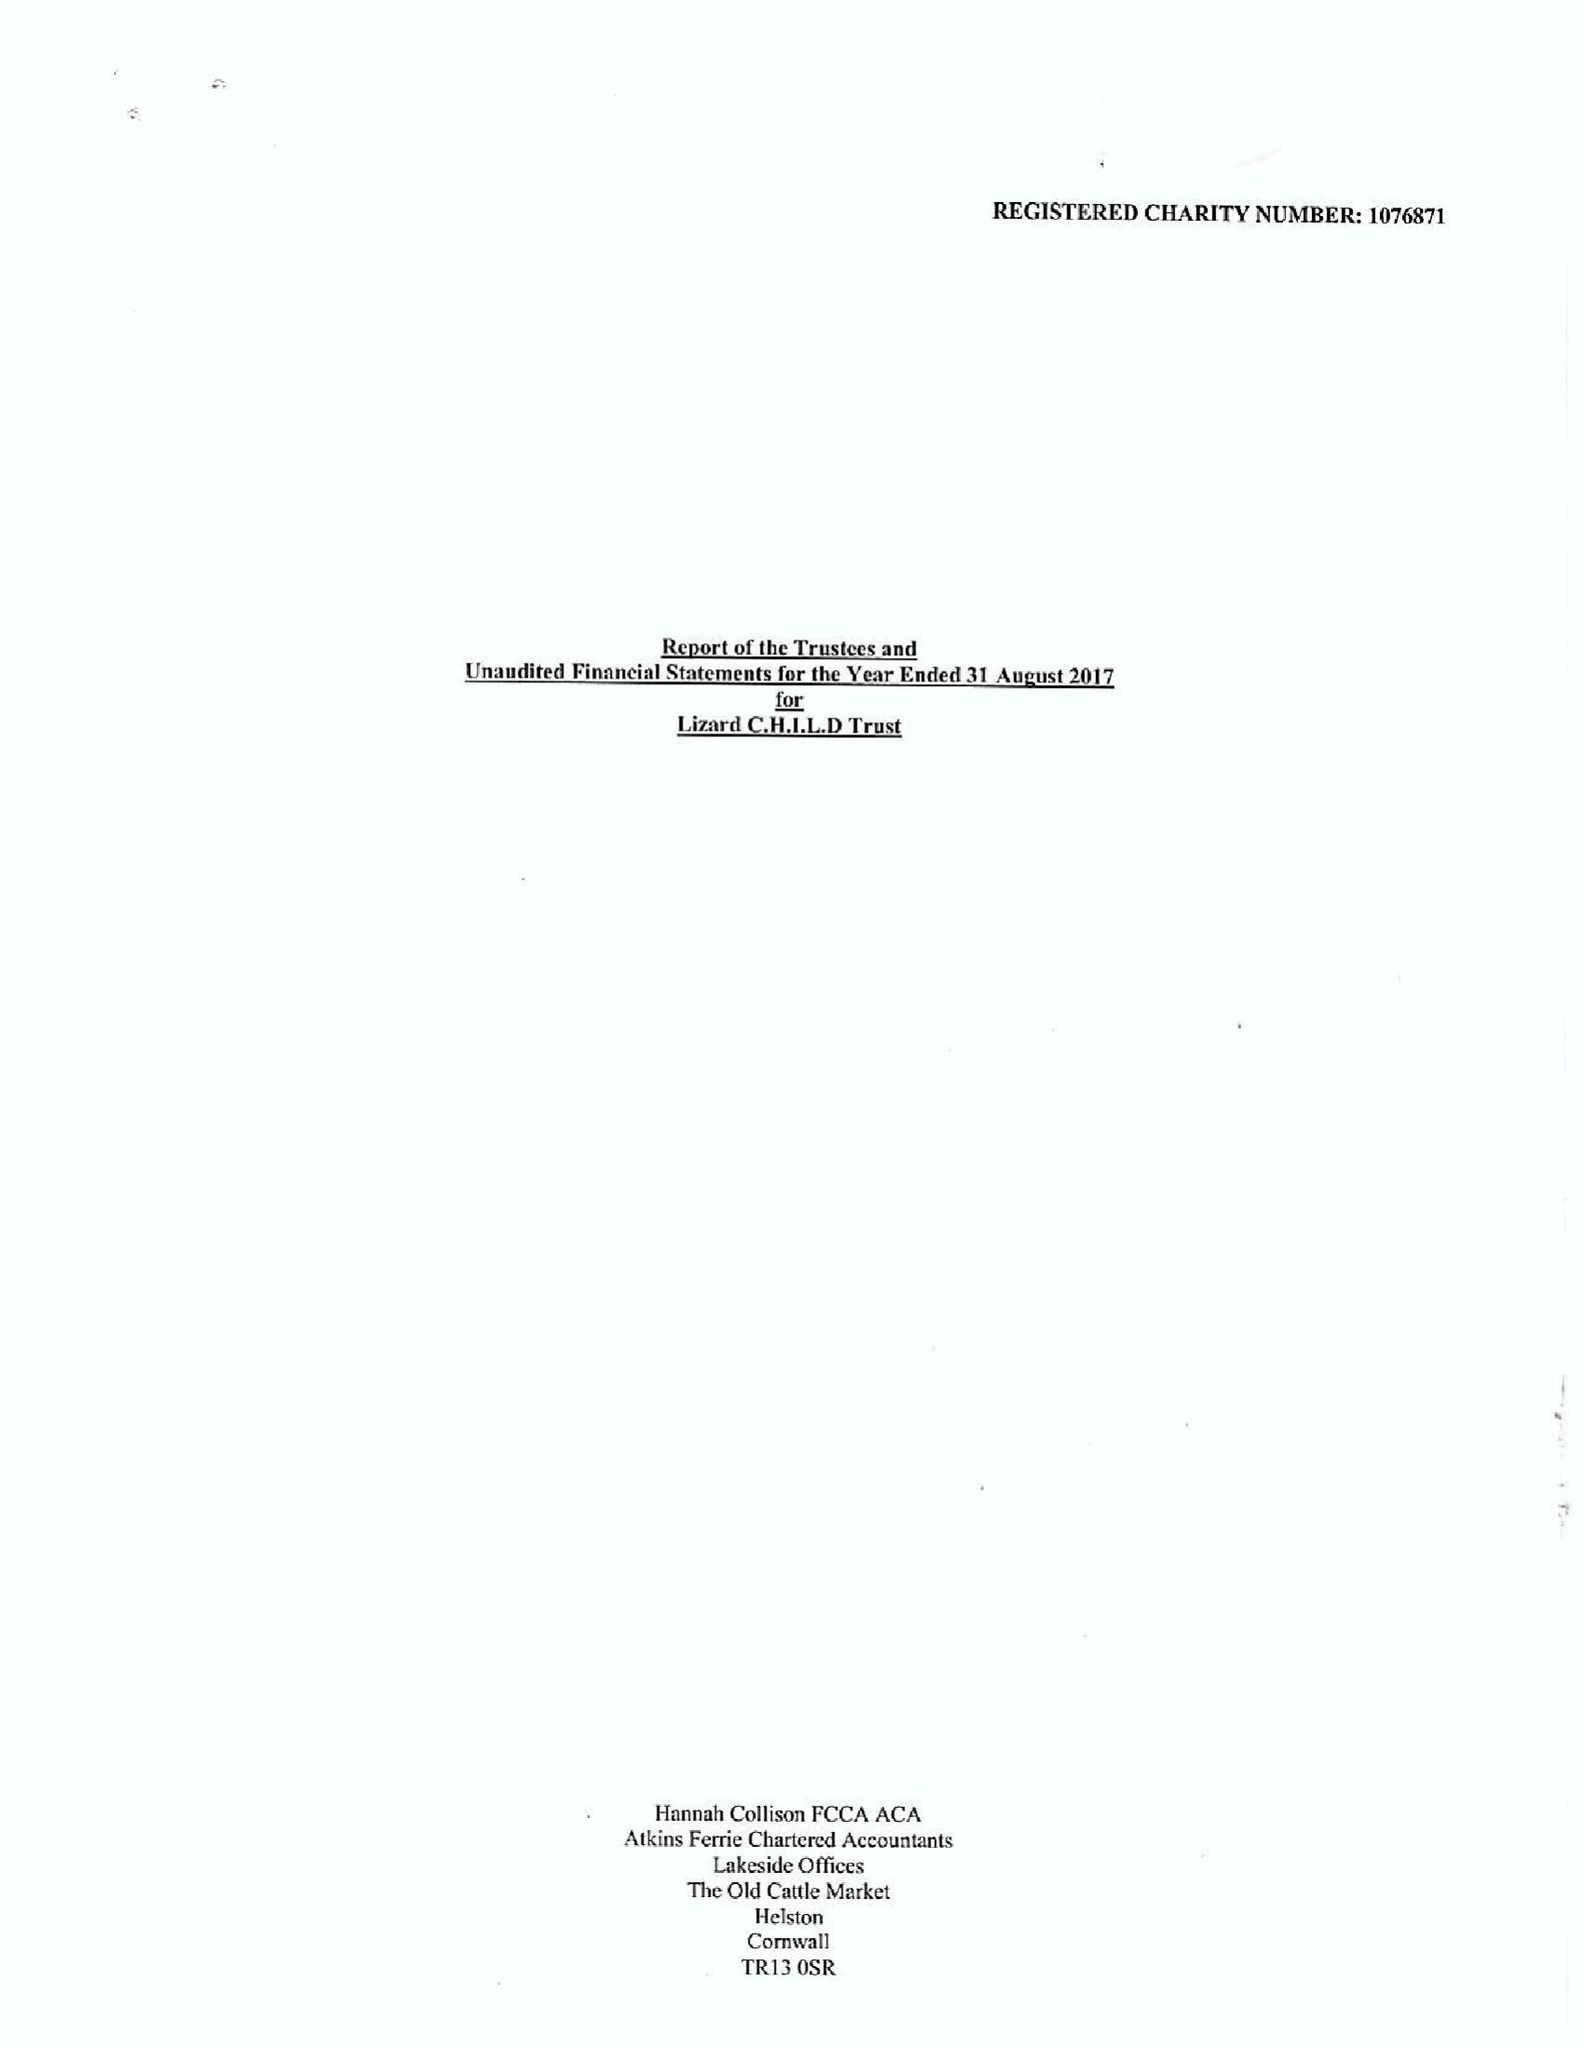What is the value for the report_date?
Answer the question using a single word or phrase. 2017-08-31 